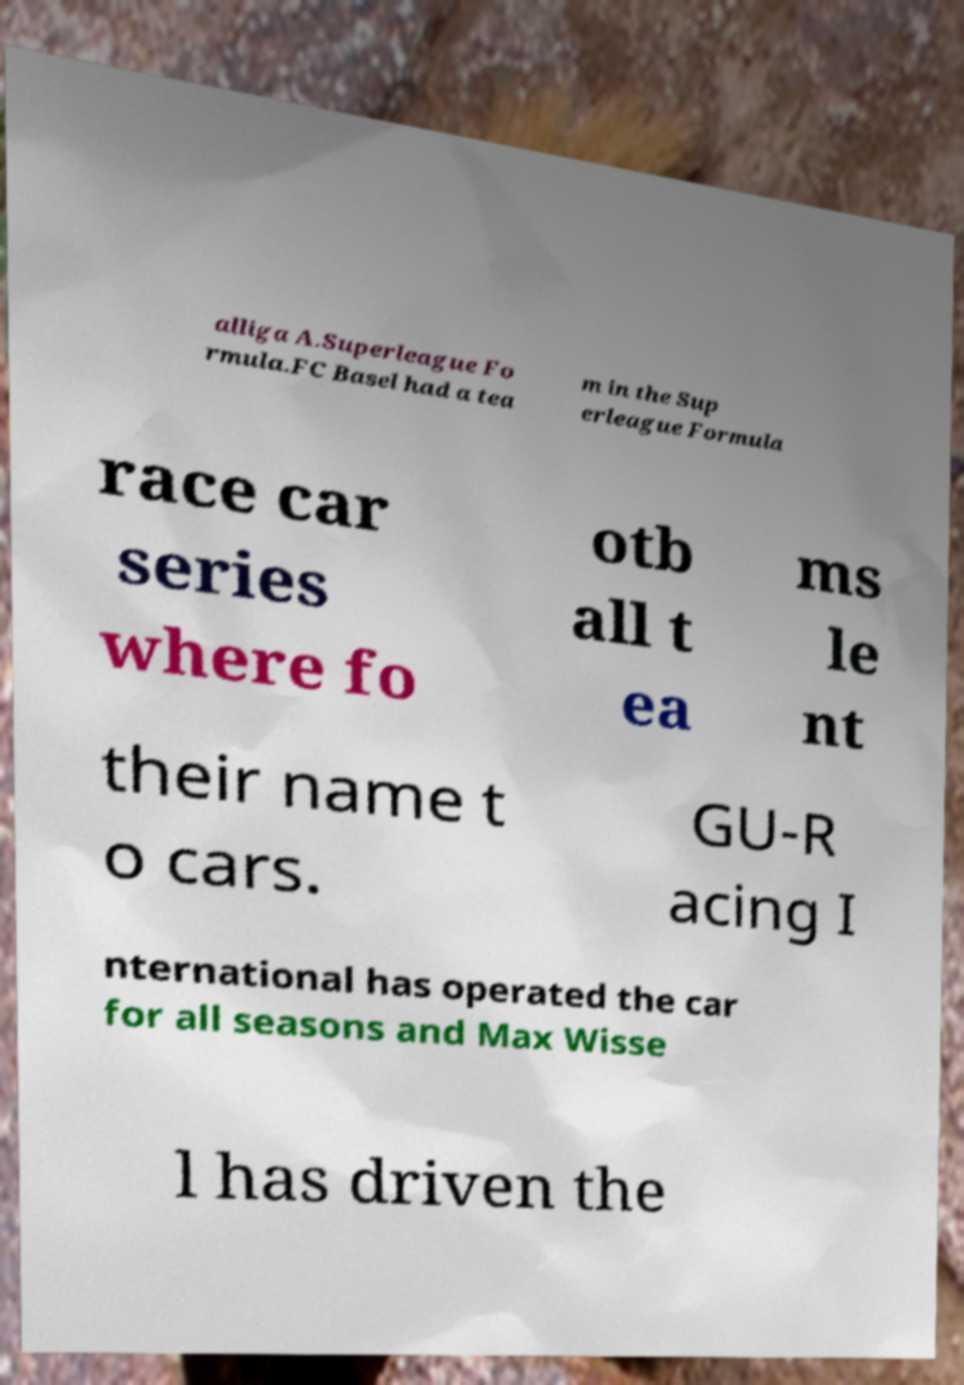For documentation purposes, I need the text within this image transcribed. Could you provide that? alliga A.Superleague Fo rmula.FC Basel had a tea m in the Sup erleague Formula race car series where fo otb all t ea ms le nt their name t o cars. GU-R acing I nternational has operated the car for all seasons and Max Wisse l has driven the 